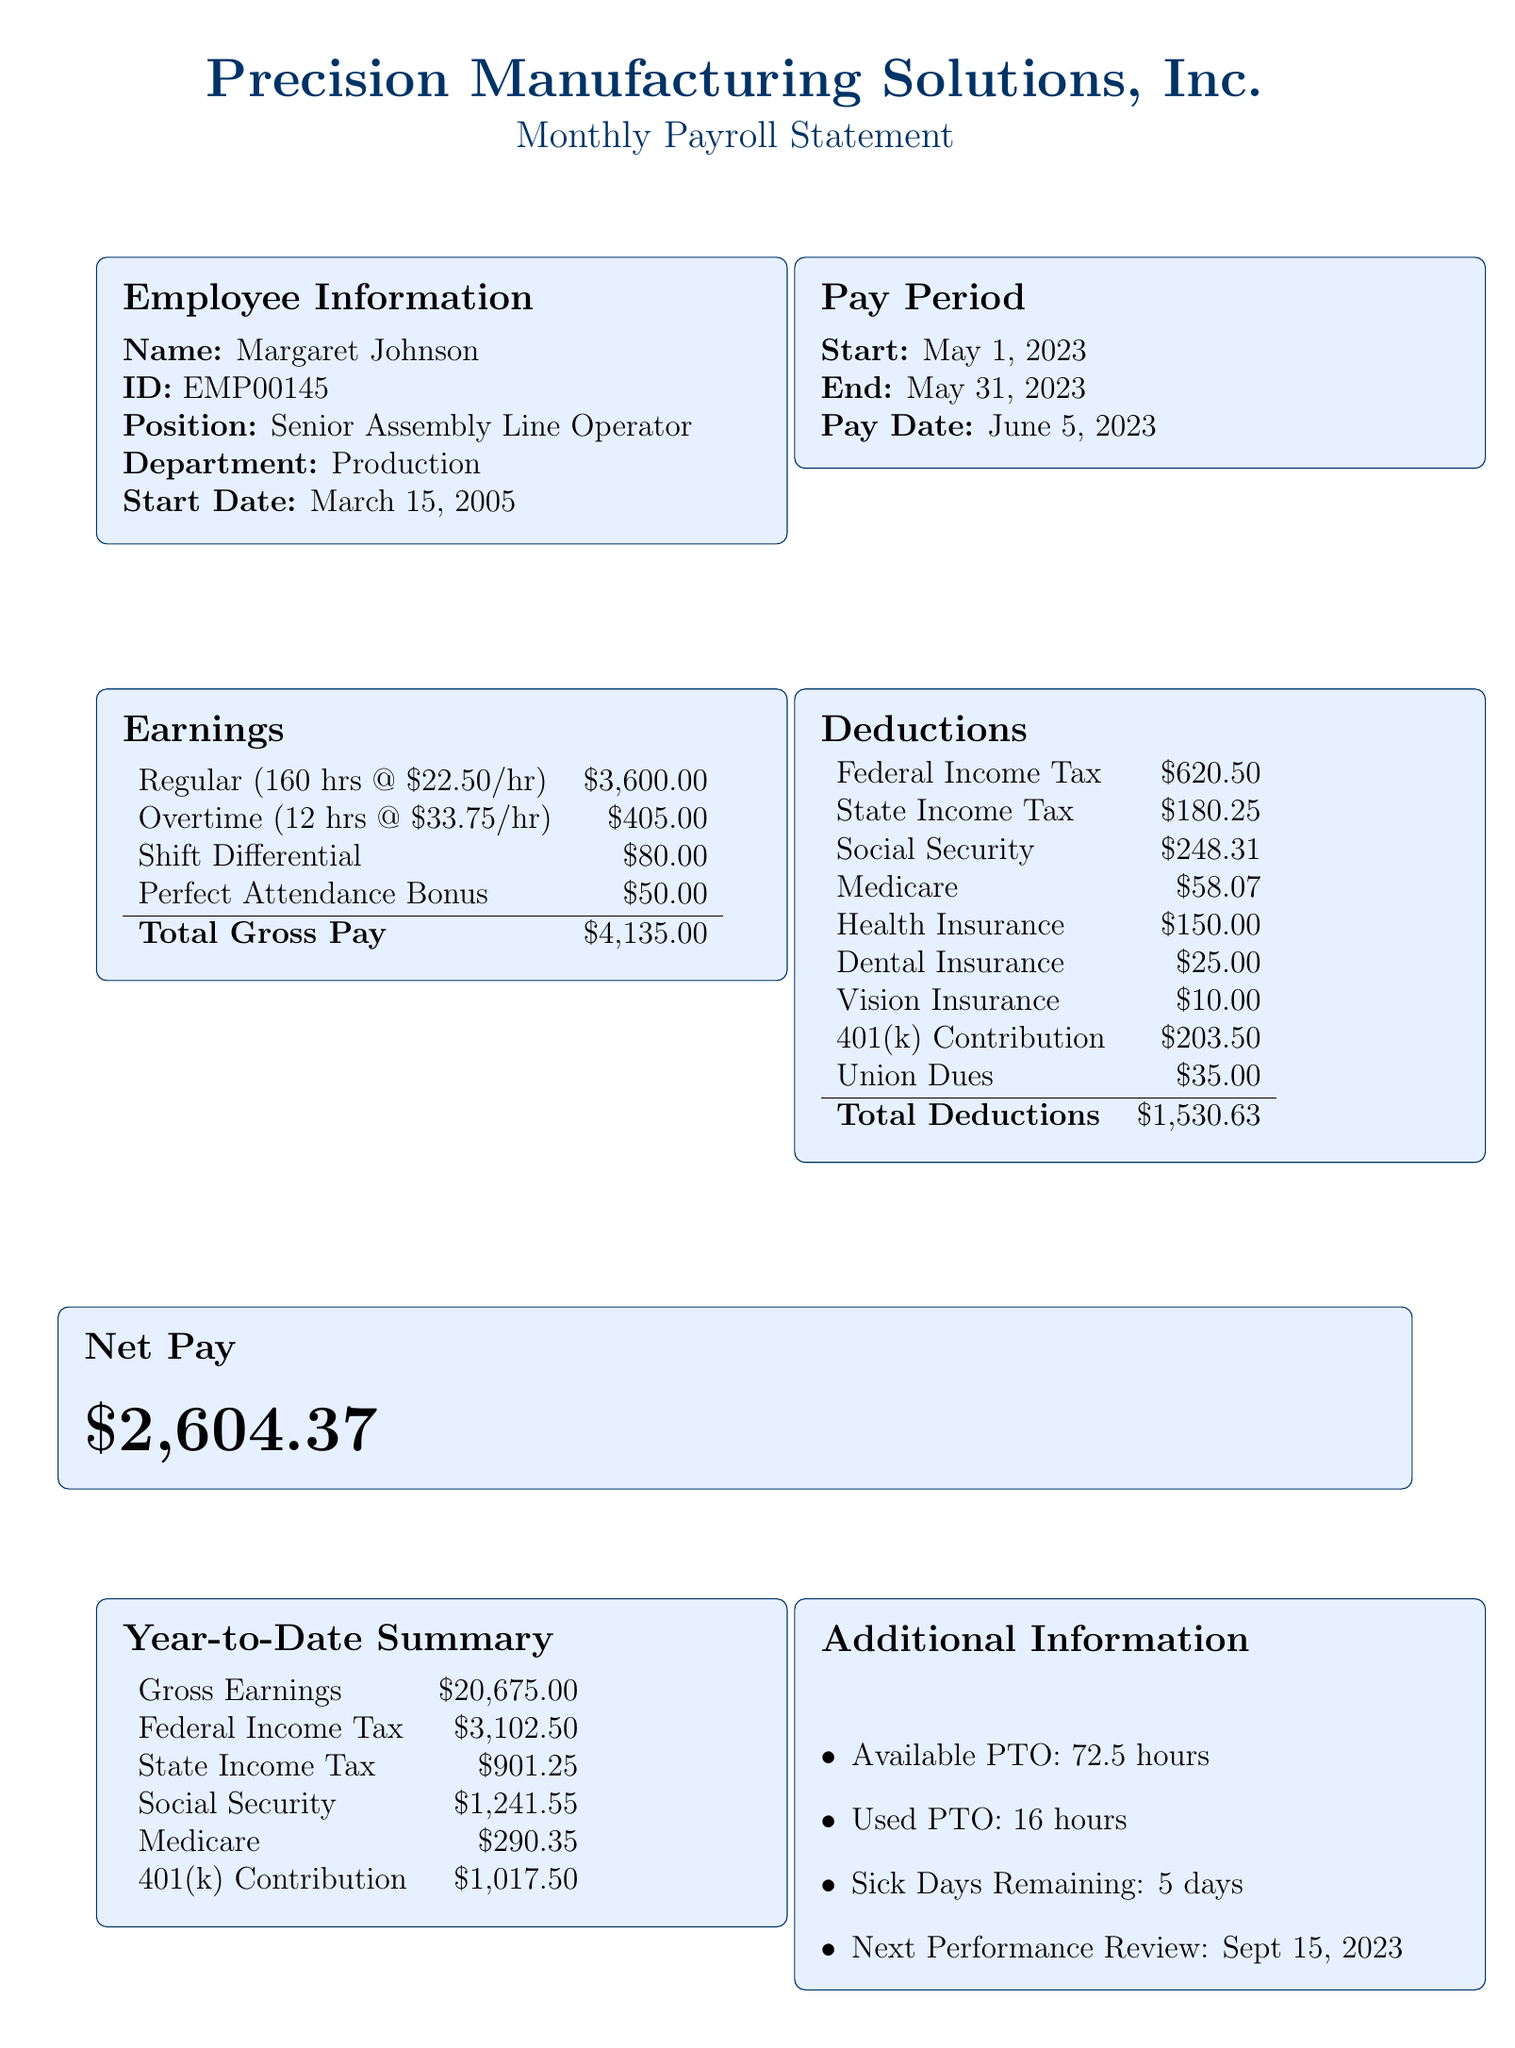What is the employee's name? The name of the employee is listed in the document under Employee Information.
Answer: Margaret Johnson What is the overtime pay? Overtime pay is calculated based on the overtime hours worked and the overtime rate.
Answer: 405.00 What are the total deductions? Total deductions are computed by summing all the deductible amounts listed in the Deductions section.
Answer: 1530.63 How many sick days are remaining? The remaining sick days are specified in the Additional Information section.
Answer: 5 What is the total gross pay? Total gross pay is the sum of all earnings listed in the document.
Answer: 4135.00 What is the position of the employee? The position of the employee is stated in the Employee Information section.
Answer: Senior Assembly Line Operator What is the pay date? The pay date is noted in the Pay Period details.
Answer: June 5, 2023 What is the next performance review date? The next performance review date is provided in the Additional Information section.
Answer: September 15, 2023 What is the shift differential amount? The shift differential amount is detailed in the Earnings section.
Answer: 80.00 